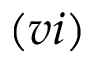Convert formula to latex. <formula><loc_0><loc_0><loc_500><loc_500>( v i )</formula> 